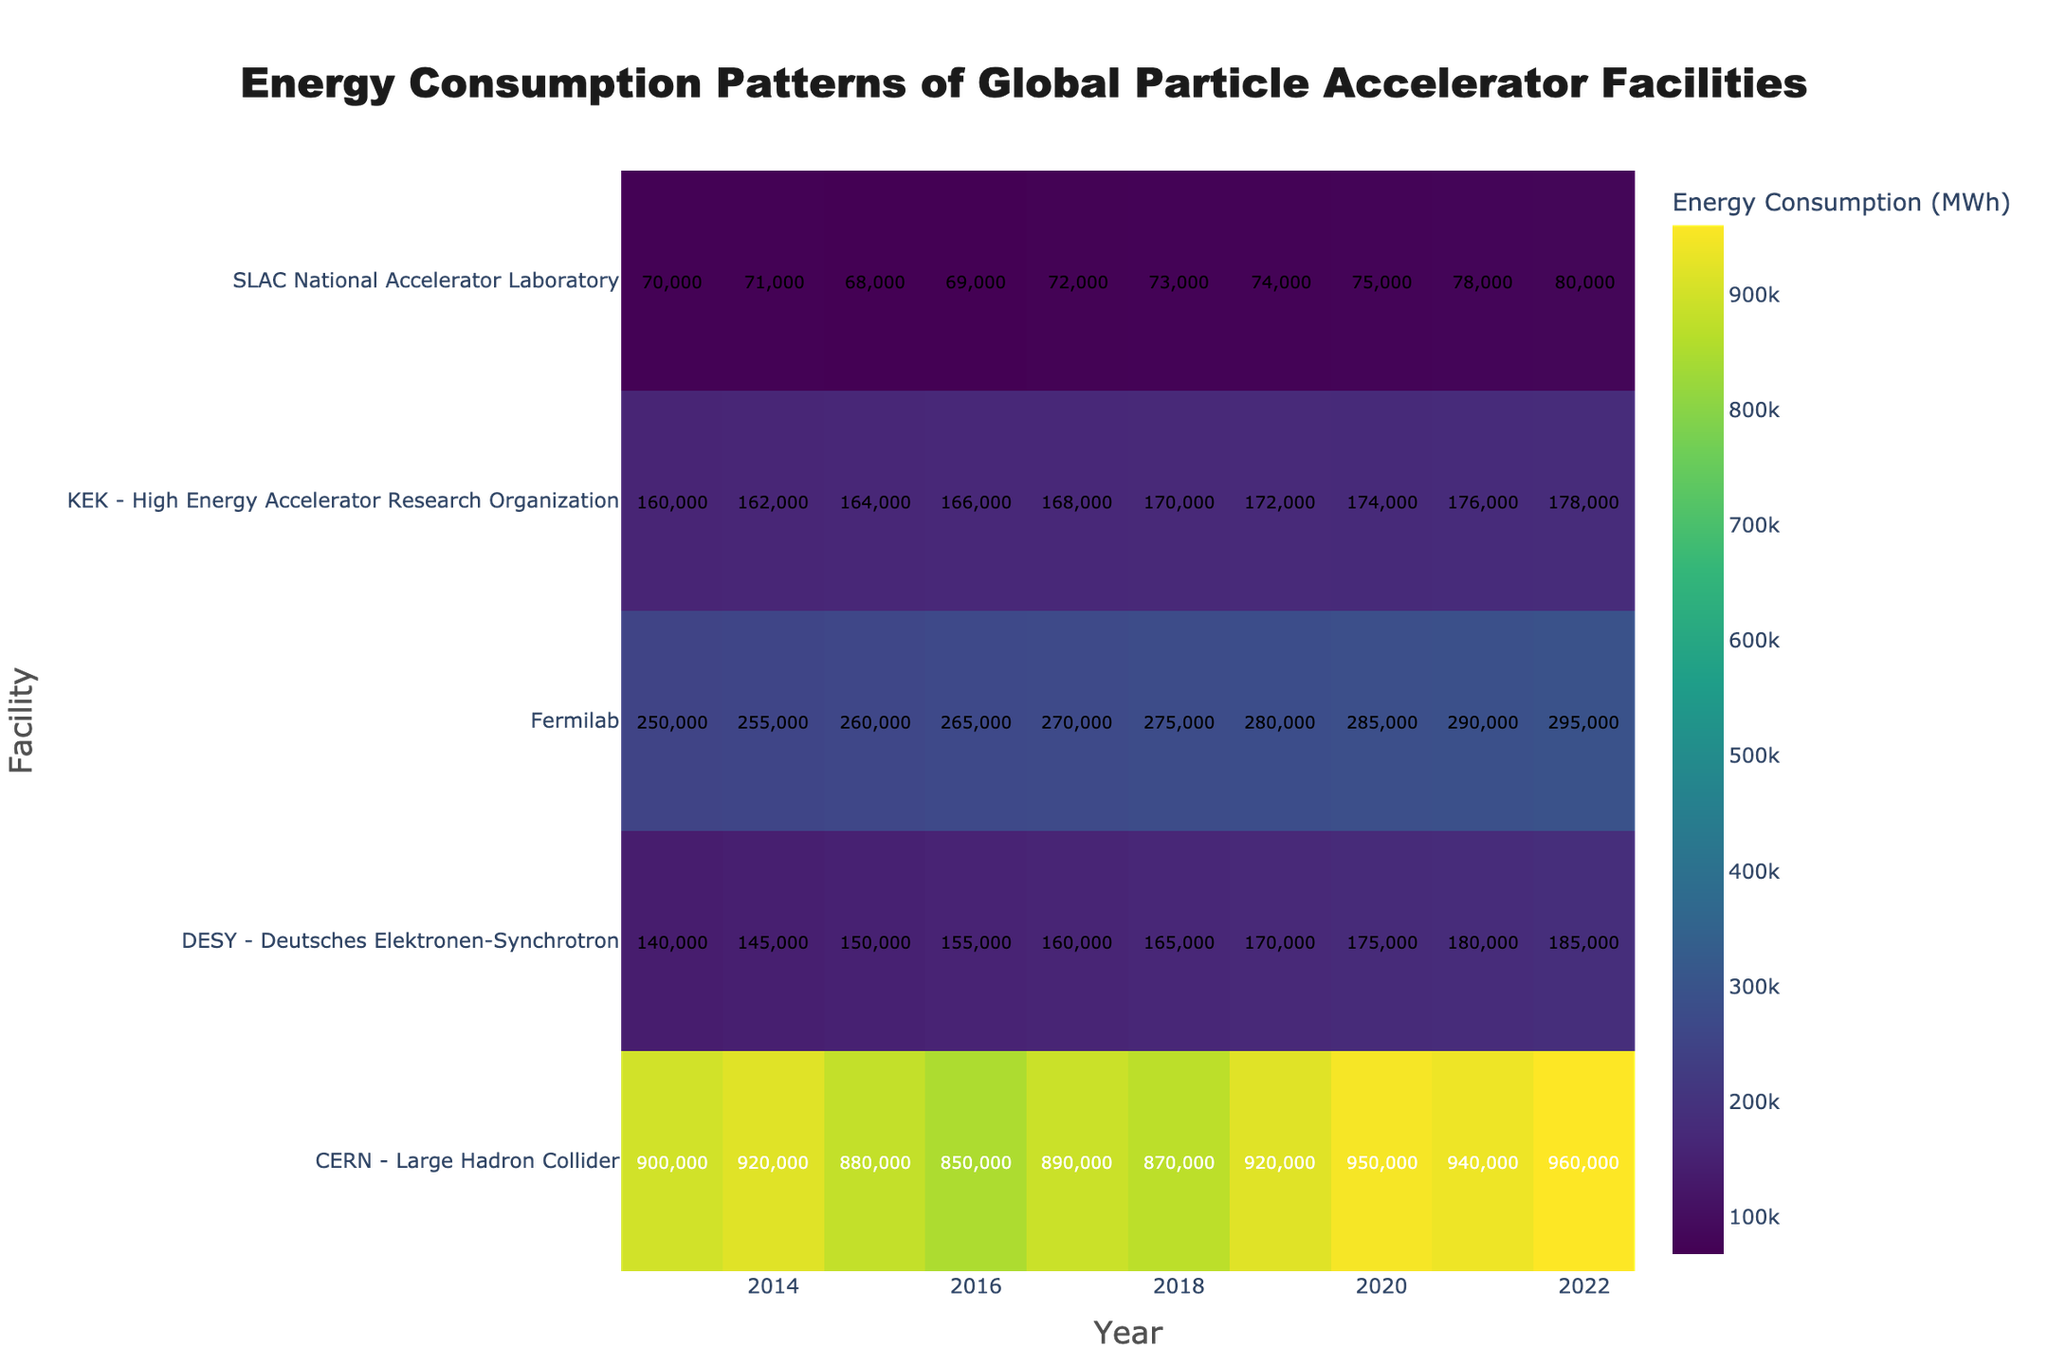What is the title of the heatmap? The title is usually found at the top of the figure. It summarizes what the figure represents. Here, the title "Energy Consumption Patterns of Global Particle Accelerator Facilities" is located at the top center of the heatmap.
Answer: Energy Consumption Patterns of Global Particle Accelerator Facilities Which facility had the highest energy consumption in 2022? To find this, look at the column for the year 2022 and identify the cell with the highest value. According to the heatmap, the CERN - Large Hadron Collider has the highest energy consumption for 2022 with 960,000 MWh.
Answer: CERN - Large Hadron Collider How has the energy consumption of Fermilab changed from 2013 to 2022? Look at the row corresponding to Fermilab and compare the energy consumption values from 2013 and 2022. Fermilab's energy consumption increased from 250,000 MWh in 2013 to 295,000 MWh in 2022.
Answer: Increased What is the average energy consumption for SLAC National Accelerator Laboratory across the decade? To find the average, sum the energy consumption values for SLAC from 2013 to 2022 and then divide by the number of years (10). The values are: 70,000, 71,000, 68,000, 69,000, 72,000, 73,000, 74,000, 75,000, 78,000, 80,000. Summing these gives 730,000 and dividing by 10 gives an average of 73,000 MWh.
Answer: 73,000 MWh Which facility showed the most consistent energy consumption over the last decade? Consistency can be observed by looking for the smallest variation in energy consumption values over the years. KEK - High Energy Accelerator Research Organization's values increase steadily without major fluctuations, indicating the most consistent energy consumption.
Answer: KEK - High Energy Accelerator Research Organization How does the energy consumption trend of DESY compare to that of CERN over the decade? Look at the trends from 2013 to 2022 for both DESY and CERN. DESY's energy consumption shows a steady increase from 140,000 MWh in 2013 to 185,000 MWh in 2022, while CERN's energy consumption fluctuates but generally increases from 900,000 MWh to 960,000 MWh in the same period. This shows that DESY has a steady increasing trend, while CERN has a fluctuating but generally increasing trend.
Answer: DESY: steady increase; CERN: fluctuating but increasing Which year had the highest combined energy consumption across all facilities? To find this, sum the energy consumption values for all facilities in each year and identify the year with the highest total. For simplicity, let’s consider the values for a couple of years: In 2022, the values are CERN: 960,000, SLAC: 80,000, Fermilab: 295,000, KEK: 178,000, DESY: 185,000. Summing these gives 1,698,000 MWh. Comparing this with other years shows that 2022 is the highest.
Answer: 2022 What is the color that represents the highest energy consumption? The color representing the highest energy consumption can be observed in the colorbar. The highest values (closer to 960,000 MWh for CERN in 2022) align with the brightest color on the Viridis color scale, which is yellow-green.
Answer: Yellow-green 